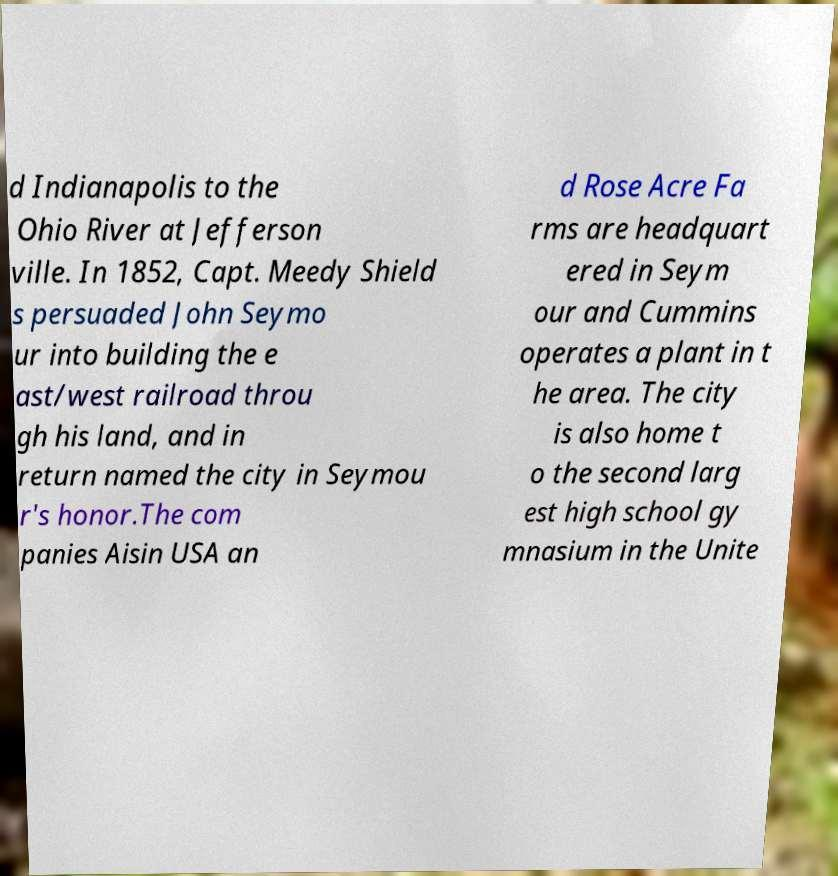Please identify and transcribe the text found in this image. d Indianapolis to the Ohio River at Jefferson ville. In 1852, Capt. Meedy Shield s persuaded John Seymo ur into building the e ast/west railroad throu gh his land, and in return named the city in Seymou r's honor.The com panies Aisin USA an d Rose Acre Fa rms are headquart ered in Seym our and Cummins operates a plant in t he area. The city is also home t o the second larg est high school gy mnasium in the Unite 